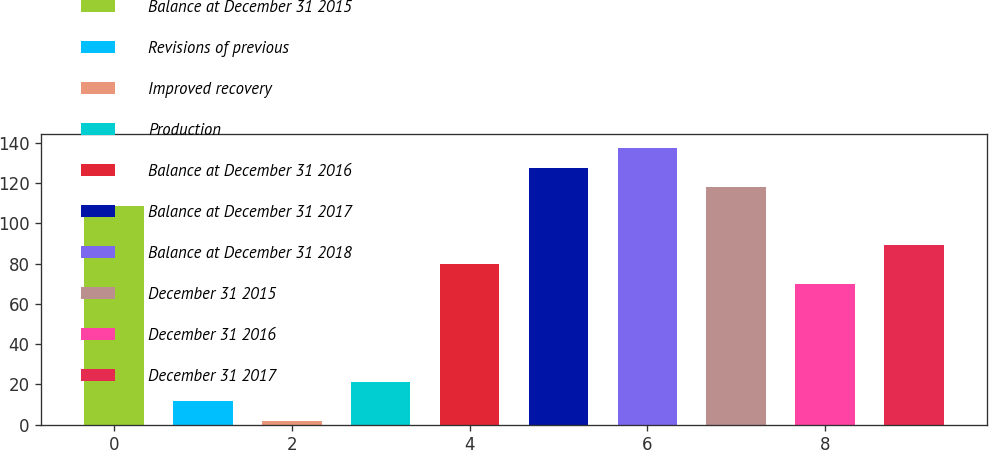Convert chart. <chart><loc_0><loc_0><loc_500><loc_500><bar_chart><fcel>Balance at December 31 2015<fcel>Revisions of previous<fcel>Improved recovery<fcel>Production<fcel>Balance at December 31 2016<fcel>Balance at December 31 2017<fcel>Balance at December 31 2018<fcel>December 31 2015<fcel>December 31 2016<fcel>December 31 2017<nl><fcel>108.4<fcel>11.6<fcel>2<fcel>21.2<fcel>79.6<fcel>127.6<fcel>137.2<fcel>118<fcel>70<fcel>89.2<nl></chart> 